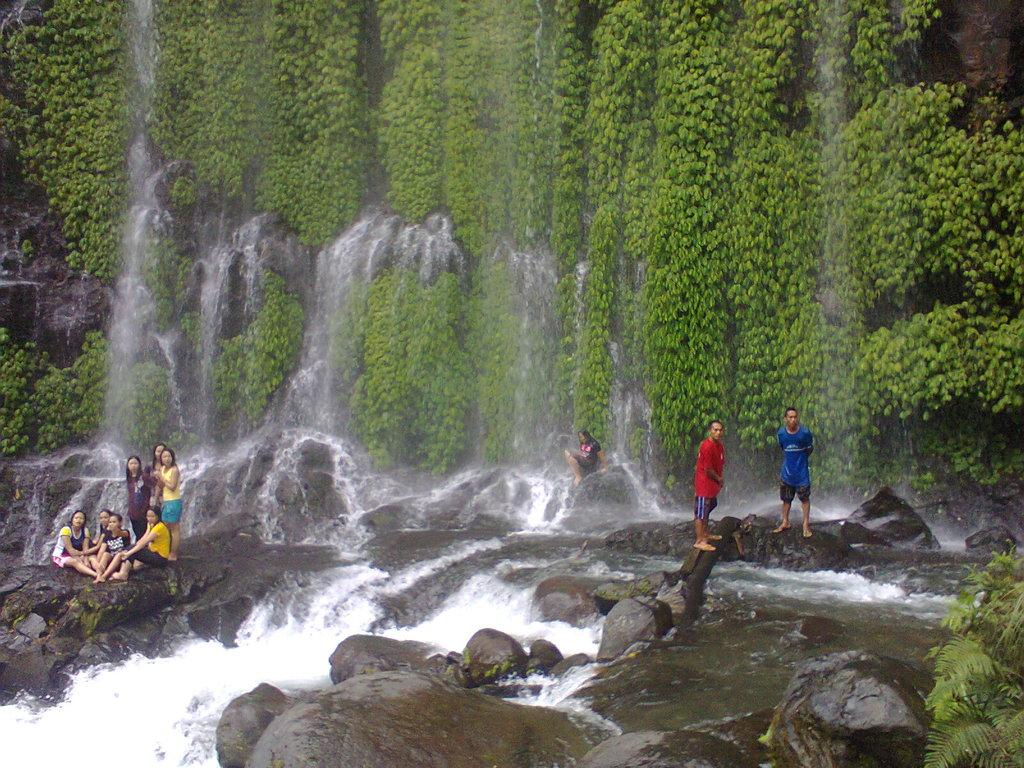What are the people in the image doing? There are people sitting on the rocks and standing in the image. What is happening to the rocks in the image? Water is flowing on the rocks in the image. What can be seen in the background of the image? There are plants in the background of the image. What type of comfort can be seen being provided by the governor in the image? There is no governor present in the image, and therefore no comfort can be provided by one. 